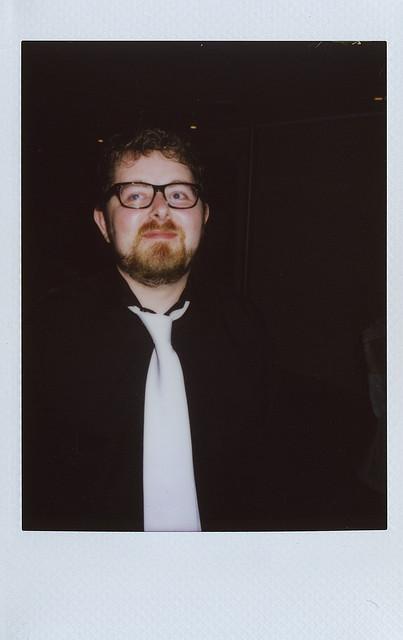What color is the tie?
Short answer required. White. Is this a new or old photos?
Concise answer only. New. Does this man have facial hair?
Answer briefly. Yes. Is he wearing sunglasses?
Answer briefly. No. 